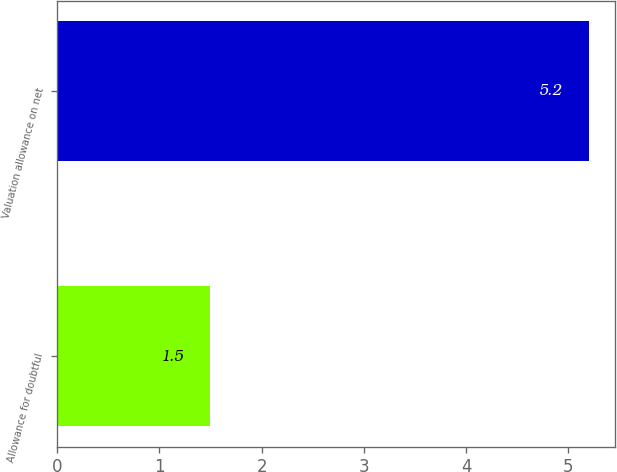Convert chart. <chart><loc_0><loc_0><loc_500><loc_500><bar_chart><fcel>Allowance for doubtful<fcel>Valuation allowance on net<nl><fcel>1.5<fcel>5.2<nl></chart> 